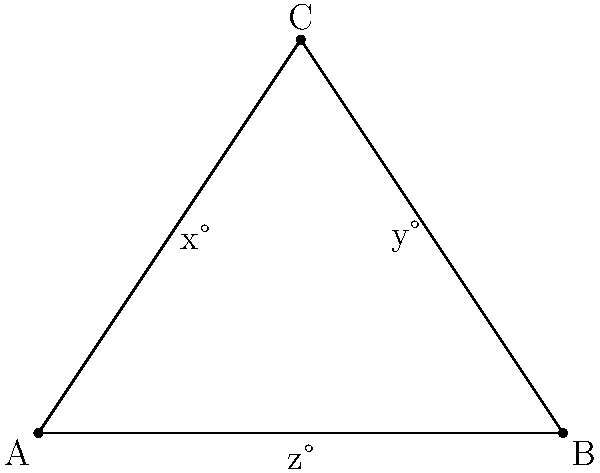In a triangular concert hall, the stage is at point C, and the audience is seated along AB. The angles formed by different seating arrangements are shown in the diagram. If $x = 40°$ and $y = 50°$, what is the value of $z$? To solve this problem, let's follow these steps:

1) In any triangle, the sum of all interior angles is always 180°.

2) From the diagram, we can see that the three angles at point C add up to 180°:
   $x° + y° + z° = 180°$

3) We are given that $x = 40°$ and $y = 50°$. Let's substitute these values:
   $40° + 50° + z° = 180°$

4) Simplify the left side of the equation:
   $90° + z° = 180°$

5) Subtract 90° from both sides to isolate $z$:
   $z° = 180° - 90° = 90°$

Therefore, the value of $z$ is 90°.
Answer: $90°$ 